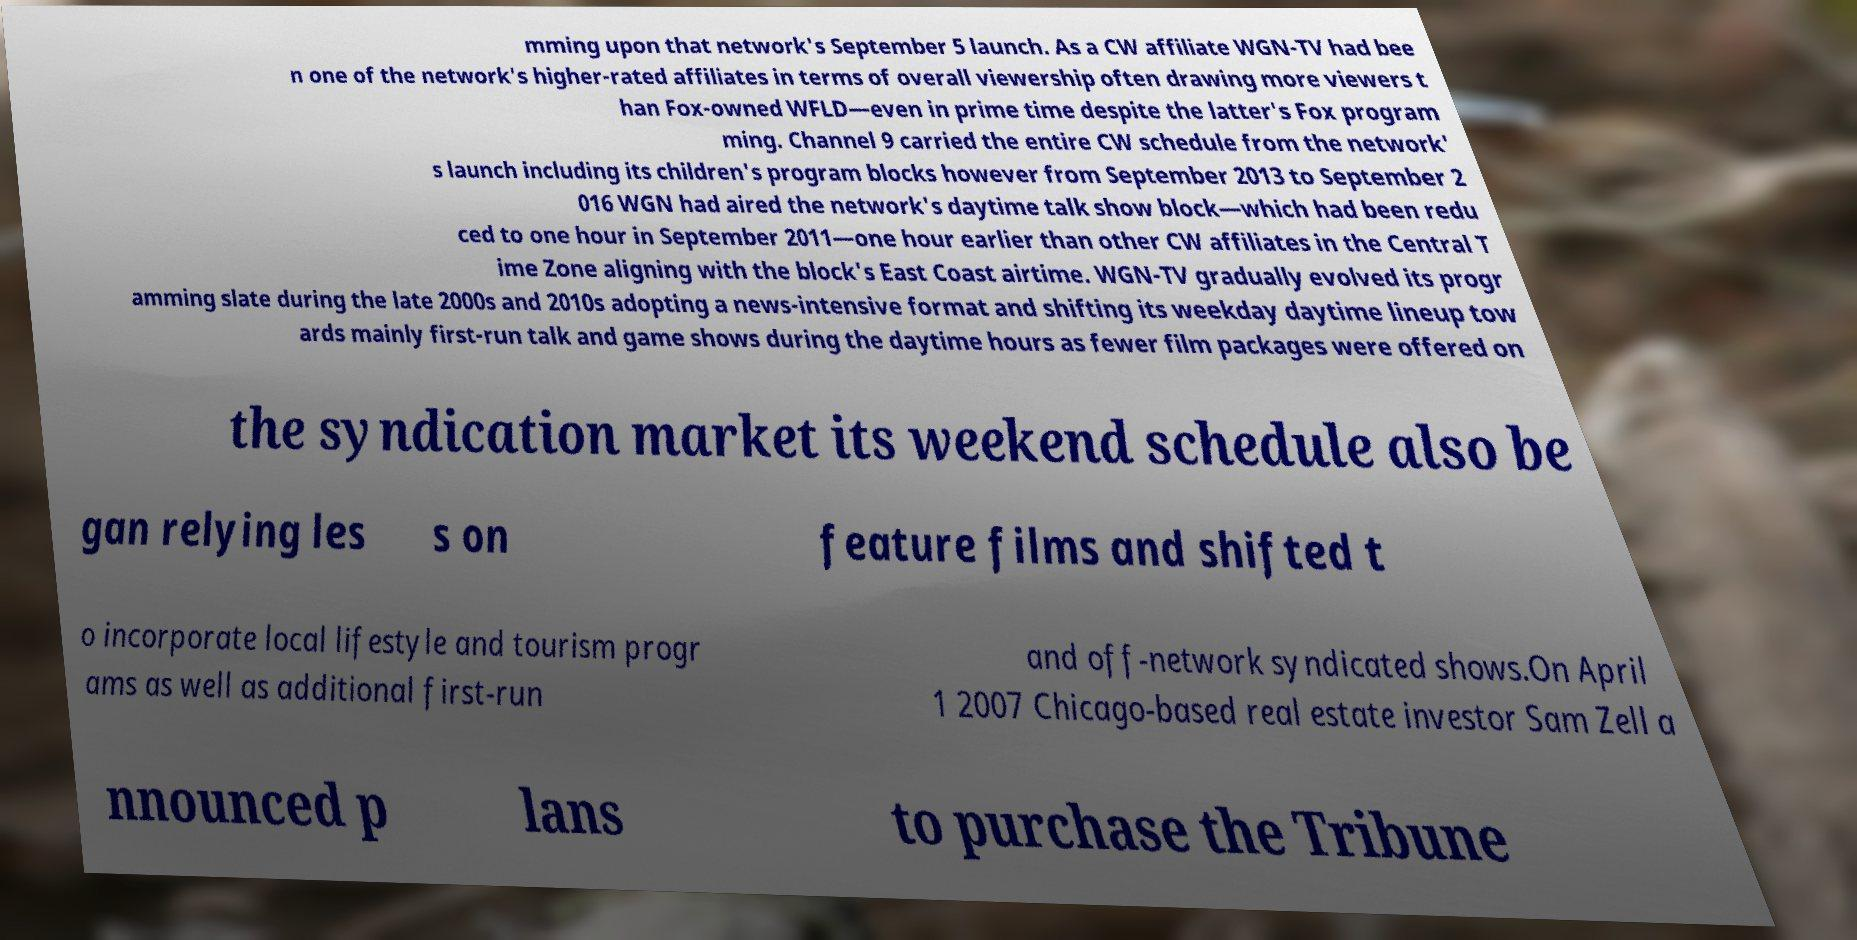For documentation purposes, I need the text within this image transcribed. Could you provide that? mming upon that network's September 5 launch. As a CW affiliate WGN-TV had bee n one of the network's higher-rated affiliates in terms of overall viewership often drawing more viewers t han Fox-owned WFLD—even in prime time despite the latter's Fox program ming. Channel 9 carried the entire CW schedule from the network' s launch including its children's program blocks however from September 2013 to September 2 016 WGN had aired the network's daytime talk show block—which had been redu ced to one hour in September 2011—one hour earlier than other CW affiliates in the Central T ime Zone aligning with the block's East Coast airtime. WGN-TV gradually evolved its progr amming slate during the late 2000s and 2010s adopting a news-intensive format and shifting its weekday daytime lineup tow ards mainly first-run talk and game shows during the daytime hours as fewer film packages were offered on the syndication market its weekend schedule also be gan relying les s on feature films and shifted t o incorporate local lifestyle and tourism progr ams as well as additional first-run and off-network syndicated shows.On April 1 2007 Chicago-based real estate investor Sam Zell a nnounced p lans to purchase the Tribune 